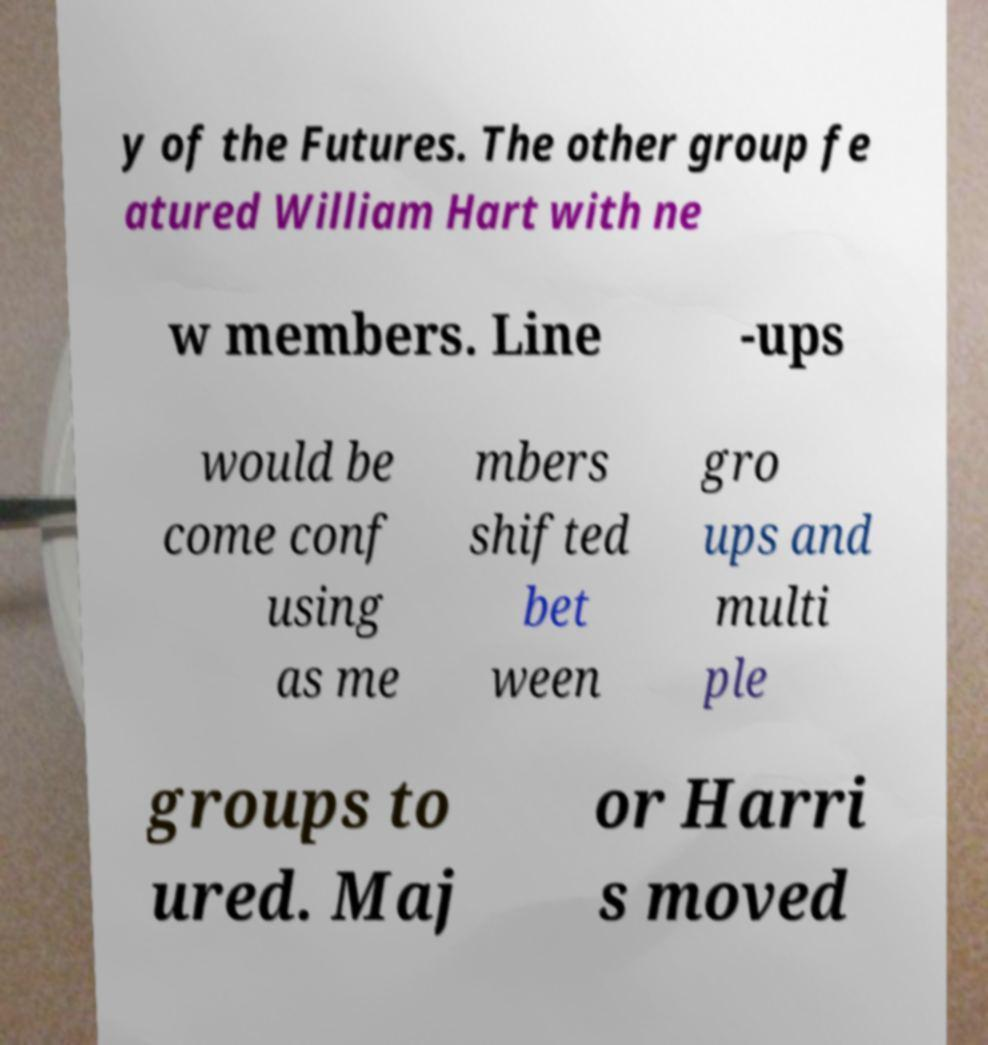There's text embedded in this image that I need extracted. Can you transcribe it verbatim? y of the Futures. The other group fe atured William Hart with ne w members. Line -ups would be come conf using as me mbers shifted bet ween gro ups and multi ple groups to ured. Maj or Harri s moved 